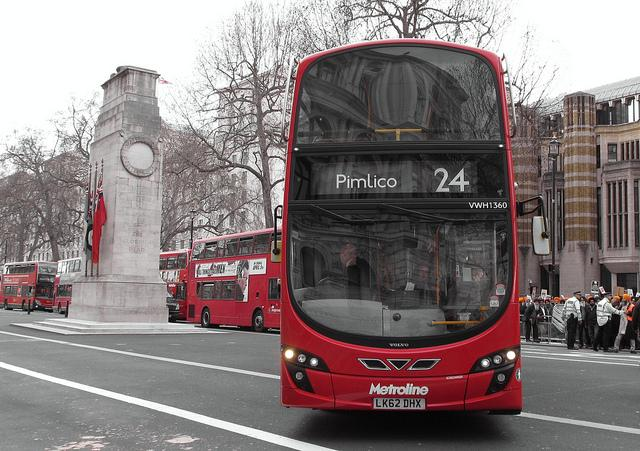Which bus company owns this bus? metroline 